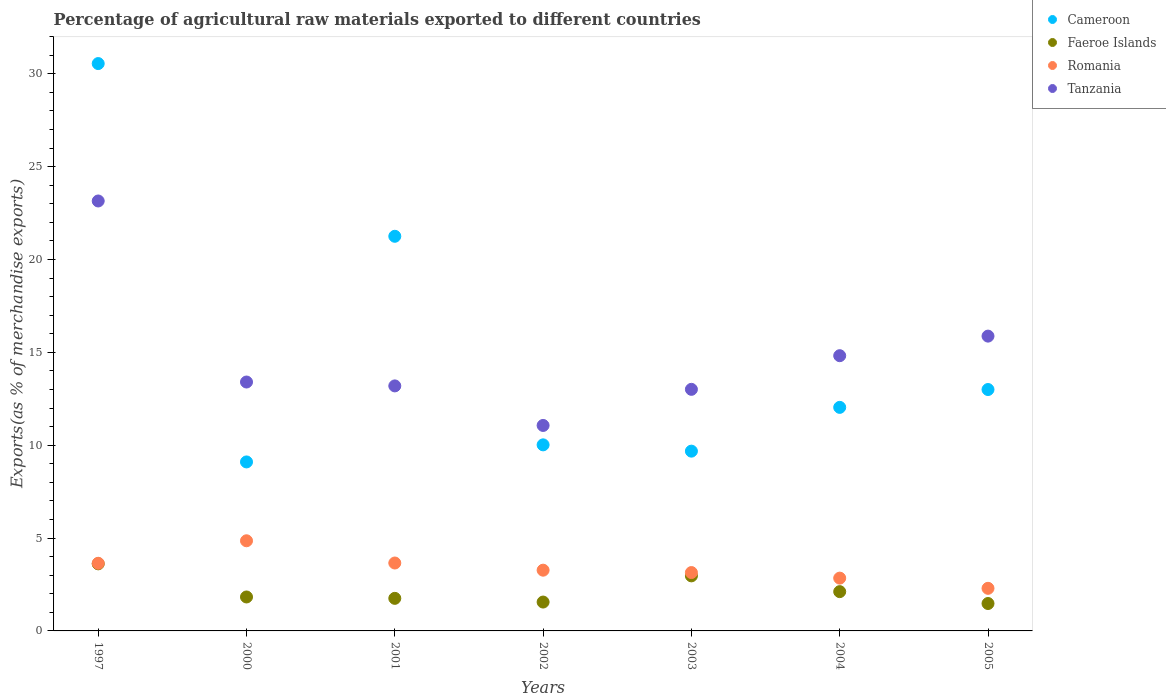How many different coloured dotlines are there?
Provide a short and direct response. 4. What is the percentage of exports to different countries in Cameroon in 2004?
Keep it short and to the point. 12.04. Across all years, what is the maximum percentage of exports to different countries in Faeroe Islands?
Offer a very short reply. 3.61. Across all years, what is the minimum percentage of exports to different countries in Cameroon?
Make the answer very short. 9.1. In which year was the percentage of exports to different countries in Cameroon maximum?
Make the answer very short. 1997. In which year was the percentage of exports to different countries in Tanzania minimum?
Keep it short and to the point. 2002. What is the total percentage of exports to different countries in Cameroon in the graph?
Your response must be concise. 105.64. What is the difference between the percentage of exports to different countries in Faeroe Islands in 2003 and that in 2004?
Provide a short and direct response. 0.85. What is the difference between the percentage of exports to different countries in Cameroon in 1997 and the percentage of exports to different countries in Tanzania in 2005?
Provide a short and direct response. 14.68. What is the average percentage of exports to different countries in Faeroe Islands per year?
Give a very brief answer. 2.19. In the year 2001, what is the difference between the percentage of exports to different countries in Cameroon and percentage of exports to different countries in Romania?
Provide a short and direct response. 17.59. What is the ratio of the percentage of exports to different countries in Tanzania in 2003 to that in 2005?
Your response must be concise. 0.82. Is the difference between the percentage of exports to different countries in Cameroon in 2001 and 2005 greater than the difference between the percentage of exports to different countries in Romania in 2001 and 2005?
Ensure brevity in your answer.  Yes. What is the difference between the highest and the second highest percentage of exports to different countries in Tanzania?
Provide a succinct answer. 7.28. What is the difference between the highest and the lowest percentage of exports to different countries in Cameroon?
Make the answer very short. 21.45. In how many years, is the percentage of exports to different countries in Romania greater than the average percentage of exports to different countries in Romania taken over all years?
Offer a terse response. 3. Is the sum of the percentage of exports to different countries in Faeroe Islands in 2002 and 2003 greater than the maximum percentage of exports to different countries in Romania across all years?
Your answer should be very brief. No. Is it the case that in every year, the sum of the percentage of exports to different countries in Romania and percentage of exports to different countries in Tanzania  is greater than the percentage of exports to different countries in Cameroon?
Your answer should be compact. No. Does the percentage of exports to different countries in Faeroe Islands monotonically increase over the years?
Provide a succinct answer. No. Is the percentage of exports to different countries in Romania strictly greater than the percentage of exports to different countries in Tanzania over the years?
Provide a succinct answer. No. How many dotlines are there?
Give a very brief answer. 4. What is the difference between two consecutive major ticks on the Y-axis?
Offer a terse response. 5. Does the graph contain grids?
Provide a short and direct response. No. Where does the legend appear in the graph?
Offer a terse response. Top right. How many legend labels are there?
Your response must be concise. 4. How are the legend labels stacked?
Your answer should be compact. Vertical. What is the title of the graph?
Your answer should be very brief. Percentage of agricultural raw materials exported to different countries. Does "Kenya" appear as one of the legend labels in the graph?
Your answer should be compact. No. What is the label or title of the X-axis?
Give a very brief answer. Years. What is the label or title of the Y-axis?
Ensure brevity in your answer.  Exports(as % of merchandise exports). What is the Exports(as % of merchandise exports) of Cameroon in 1997?
Your answer should be very brief. 30.55. What is the Exports(as % of merchandise exports) of Faeroe Islands in 1997?
Keep it short and to the point. 3.61. What is the Exports(as % of merchandise exports) of Romania in 1997?
Your response must be concise. 3.64. What is the Exports(as % of merchandise exports) in Tanzania in 1997?
Give a very brief answer. 23.15. What is the Exports(as % of merchandise exports) in Cameroon in 2000?
Offer a terse response. 9.1. What is the Exports(as % of merchandise exports) of Faeroe Islands in 2000?
Ensure brevity in your answer.  1.83. What is the Exports(as % of merchandise exports) in Romania in 2000?
Keep it short and to the point. 4.85. What is the Exports(as % of merchandise exports) of Tanzania in 2000?
Offer a very short reply. 13.4. What is the Exports(as % of merchandise exports) of Cameroon in 2001?
Keep it short and to the point. 21.25. What is the Exports(as % of merchandise exports) of Faeroe Islands in 2001?
Make the answer very short. 1.75. What is the Exports(as % of merchandise exports) of Romania in 2001?
Make the answer very short. 3.66. What is the Exports(as % of merchandise exports) of Tanzania in 2001?
Make the answer very short. 13.19. What is the Exports(as % of merchandise exports) in Cameroon in 2002?
Keep it short and to the point. 10.02. What is the Exports(as % of merchandise exports) of Faeroe Islands in 2002?
Offer a very short reply. 1.55. What is the Exports(as % of merchandise exports) in Romania in 2002?
Keep it short and to the point. 3.27. What is the Exports(as % of merchandise exports) in Tanzania in 2002?
Your answer should be compact. 11.06. What is the Exports(as % of merchandise exports) of Cameroon in 2003?
Your answer should be very brief. 9.68. What is the Exports(as % of merchandise exports) of Faeroe Islands in 2003?
Provide a short and direct response. 2.96. What is the Exports(as % of merchandise exports) in Romania in 2003?
Make the answer very short. 3.14. What is the Exports(as % of merchandise exports) of Tanzania in 2003?
Ensure brevity in your answer.  13.01. What is the Exports(as % of merchandise exports) in Cameroon in 2004?
Ensure brevity in your answer.  12.04. What is the Exports(as % of merchandise exports) in Faeroe Islands in 2004?
Make the answer very short. 2.12. What is the Exports(as % of merchandise exports) of Romania in 2004?
Make the answer very short. 2.84. What is the Exports(as % of merchandise exports) in Tanzania in 2004?
Provide a succinct answer. 14.82. What is the Exports(as % of merchandise exports) of Cameroon in 2005?
Your response must be concise. 13. What is the Exports(as % of merchandise exports) in Faeroe Islands in 2005?
Provide a succinct answer. 1.48. What is the Exports(as % of merchandise exports) in Romania in 2005?
Your response must be concise. 2.29. What is the Exports(as % of merchandise exports) in Tanzania in 2005?
Give a very brief answer. 15.87. Across all years, what is the maximum Exports(as % of merchandise exports) in Cameroon?
Keep it short and to the point. 30.55. Across all years, what is the maximum Exports(as % of merchandise exports) of Faeroe Islands?
Offer a terse response. 3.61. Across all years, what is the maximum Exports(as % of merchandise exports) of Romania?
Your answer should be very brief. 4.85. Across all years, what is the maximum Exports(as % of merchandise exports) in Tanzania?
Your answer should be compact. 23.15. Across all years, what is the minimum Exports(as % of merchandise exports) of Cameroon?
Provide a succinct answer. 9.1. Across all years, what is the minimum Exports(as % of merchandise exports) of Faeroe Islands?
Provide a succinct answer. 1.48. Across all years, what is the minimum Exports(as % of merchandise exports) in Romania?
Make the answer very short. 2.29. Across all years, what is the minimum Exports(as % of merchandise exports) of Tanzania?
Give a very brief answer. 11.06. What is the total Exports(as % of merchandise exports) of Cameroon in the graph?
Provide a succinct answer. 105.64. What is the total Exports(as % of merchandise exports) of Faeroe Islands in the graph?
Your answer should be compact. 15.3. What is the total Exports(as % of merchandise exports) of Romania in the graph?
Ensure brevity in your answer.  23.7. What is the total Exports(as % of merchandise exports) in Tanzania in the graph?
Give a very brief answer. 104.52. What is the difference between the Exports(as % of merchandise exports) of Cameroon in 1997 and that in 2000?
Keep it short and to the point. 21.45. What is the difference between the Exports(as % of merchandise exports) of Faeroe Islands in 1997 and that in 2000?
Your answer should be very brief. 1.78. What is the difference between the Exports(as % of merchandise exports) of Romania in 1997 and that in 2000?
Ensure brevity in your answer.  -1.21. What is the difference between the Exports(as % of merchandise exports) of Tanzania in 1997 and that in 2000?
Your answer should be compact. 9.75. What is the difference between the Exports(as % of merchandise exports) in Cameroon in 1997 and that in 2001?
Ensure brevity in your answer.  9.3. What is the difference between the Exports(as % of merchandise exports) in Faeroe Islands in 1997 and that in 2001?
Offer a terse response. 1.86. What is the difference between the Exports(as % of merchandise exports) of Romania in 1997 and that in 2001?
Your answer should be compact. -0.01. What is the difference between the Exports(as % of merchandise exports) of Tanzania in 1997 and that in 2001?
Give a very brief answer. 9.96. What is the difference between the Exports(as % of merchandise exports) in Cameroon in 1997 and that in 2002?
Offer a terse response. 20.53. What is the difference between the Exports(as % of merchandise exports) in Faeroe Islands in 1997 and that in 2002?
Keep it short and to the point. 2.06. What is the difference between the Exports(as % of merchandise exports) in Romania in 1997 and that in 2002?
Make the answer very short. 0.37. What is the difference between the Exports(as % of merchandise exports) of Tanzania in 1997 and that in 2002?
Provide a short and direct response. 12.09. What is the difference between the Exports(as % of merchandise exports) in Cameroon in 1997 and that in 2003?
Your response must be concise. 20.87. What is the difference between the Exports(as % of merchandise exports) of Faeroe Islands in 1997 and that in 2003?
Offer a terse response. 0.65. What is the difference between the Exports(as % of merchandise exports) in Romania in 1997 and that in 2003?
Provide a succinct answer. 0.5. What is the difference between the Exports(as % of merchandise exports) in Tanzania in 1997 and that in 2003?
Offer a terse response. 10.14. What is the difference between the Exports(as % of merchandise exports) in Cameroon in 1997 and that in 2004?
Provide a short and direct response. 18.51. What is the difference between the Exports(as % of merchandise exports) in Faeroe Islands in 1997 and that in 2004?
Provide a short and direct response. 1.5. What is the difference between the Exports(as % of merchandise exports) of Romania in 1997 and that in 2004?
Your response must be concise. 0.8. What is the difference between the Exports(as % of merchandise exports) in Tanzania in 1997 and that in 2004?
Your answer should be compact. 8.33. What is the difference between the Exports(as % of merchandise exports) in Cameroon in 1997 and that in 2005?
Your answer should be very brief. 17.55. What is the difference between the Exports(as % of merchandise exports) of Faeroe Islands in 1997 and that in 2005?
Your answer should be compact. 2.14. What is the difference between the Exports(as % of merchandise exports) of Romania in 1997 and that in 2005?
Offer a terse response. 1.35. What is the difference between the Exports(as % of merchandise exports) of Tanzania in 1997 and that in 2005?
Your answer should be compact. 7.28. What is the difference between the Exports(as % of merchandise exports) in Cameroon in 2000 and that in 2001?
Your response must be concise. -12.15. What is the difference between the Exports(as % of merchandise exports) in Faeroe Islands in 2000 and that in 2001?
Make the answer very short. 0.07. What is the difference between the Exports(as % of merchandise exports) of Romania in 2000 and that in 2001?
Your answer should be very brief. 1.2. What is the difference between the Exports(as % of merchandise exports) of Tanzania in 2000 and that in 2001?
Your answer should be very brief. 0.21. What is the difference between the Exports(as % of merchandise exports) of Cameroon in 2000 and that in 2002?
Offer a very short reply. -0.92. What is the difference between the Exports(as % of merchandise exports) of Faeroe Islands in 2000 and that in 2002?
Your answer should be very brief. 0.27. What is the difference between the Exports(as % of merchandise exports) of Romania in 2000 and that in 2002?
Provide a succinct answer. 1.58. What is the difference between the Exports(as % of merchandise exports) in Tanzania in 2000 and that in 2002?
Ensure brevity in your answer.  2.34. What is the difference between the Exports(as % of merchandise exports) of Cameroon in 2000 and that in 2003?
Offer a very short reply. -0.58. What is the difference between the Exports(as % of merchandise exports) in Faeroe Islands in 2000 and that in 2003?
Ensure brevity in your answer.  -1.14. What is the difference between the Exports(as % of merchandise exports) of Romania in 2000 and that in 2003?
Make the answer very short. 1.71. What is the difference between the Exports(as % of merchandise exports) of Tanzania in 2000 and that in 2003?
Make the answer very short. 0.39. What is the difference between the Exports(as % of merchandise exports) of Cameroon in 2000 and that in 2004?
Offer a terse response. -2.94. What is the difference between the Exports(as % of merchandise exports) in Faeroe Islands in 2000 and that in 2004?
Offer a very short reply. -0.29. What is the difference between the Exports(as % of merchandise exports) in Romania in 2000 and that in 2004?
Your response must be concise. 2.01. What is the difference between the Exports(as % of merchandise exports) in Tanzania in 2000 and that in 2004?
Provide a succinct answer. -1.42. What is the difference between the Exports(as % of merchandise exports) in Cameroon in 2000 and that in 2005?
Your answer should be very brief. -3.9. What is the difference between the Exports(as % of merchandise exports) of Faeroe Islands in 2000 and that in 2005?
Your answer should be very brief. 0.35. What is the difference between the Exports(as % of merchandise exports) in Romania in 2000 and that in 2005?
Your response must be concise. 2.56. What is the difference between the Exports(as % of merchandise exports) of Tanzania in 2000 and that in 2005?
Offer a very short reply. -2.47. What is the difference between the Exports(as % of merchandise exports) in Cameroon in 2001 and that in 2002?
Your answer should be very brief. 11.23. What is the difference between the Exports(as % of merchandise exports) in Faeroe Islands in 2001 and that in 2002?
Provide a short and direct response. 0.2. What is the difference between the Exports(as % of merchandise exports) in Romania in 2001 and that in 2002?
Ensure brevity in your answer.  0.39. What is the difference between the Exports(as % of merchandise exports) in Tanzania in 2001 and that in 2002?
Your response must be concise. 2.13. What is the difference between the Exports(as % of merchandise exports) of Cameroon in 2001 and that in 2003?
Make the answer very short. 11.57. What is the difference between the Exports(as % of merchandise exports) of Faeroe Islands in 2001 and that in 2003?
Provide a short and direct response. -1.21. What is the difference between the Exports(as % of merchandise exports) of Romania in 2001 and that in 2003?
Keep it short and to the point. 0.51. What is the difference between the Exports(as % of merchandise exports) in Tanzania in 2001 and that in 2003?
Your answer should be very brief. 0.18. What is the difference between the Exports(as % of merchandise exports) of Cameroon in 2001 and that in 2004?
Your answer should be compact. 9.21. What is the difference between the Exports(as % of merchandise exports) of Faeroe Islands in 2001 and that in 2004?
Provide a short and direct response. -0.36. What is the difference between the Exports(as % of merchandise exports) of Romania in 2001 and that in 2004?
Your response must be concise. 0.81. What is the difference between the Exports(as % of merchandise exports) in Tanzania in 2001 and that in 2004?
Give a very brief answer. -1.63. What is the difference between the Exports(as % of merchandise exports) in Cameroon in 2001 and that in 2005?
Ensure brevity in your answer.  8.25. What is the difference between the Exports(as % of merchandise exports) in Faeroe Islands in 2001 and that in 2005?
Provide a short and direct response. 0.28. What is the difference between the Exports(as % of merchandise exports) of Romania in 2001 and that in 2005?
Make the answer very short. 1.36. What is the difference between the Exports(as % of merchandise exports) in Tanzania in 2001 and that in 2005?
Provide a succinct answer. -2.68. What is the difference between the Exports(as % of merchandise exports) of Cameroon in 2002 and that in 2003?
Ensure brevity in your answer.  0.34. What is the difference between the Exports(as % of merchandise exports) in Faeroe Islands in 2002 and that in 2003?
Make the answer very short. -1.41. What is the difference between the Exports(as % of merchandise exports) of Romania in 2002 and that in 2003?
Your answer should be very brief. 0.13. What is the difference between the Exports(as % of merchandise exports) in Tanzania in 2002 and that in 2003?
Your response must be concise. -1.94. What is the difference between the Exports(as % of merchandise exports) of Cameroon in 2002 and that in 2004?
Provide a short and direct response. -2.02. What is the difference between the Exports(as % of merchandise exports) in Faeroe Islands in 2002 and that in 2004?
Offer a terse response. -0.56. What is the difference between the Exports(as % of merchandise exports) of Romania in 2002 and that in 2004?
Give a very brief answer. 0.43. What is the difference between the Exports(as % of merchandise exports) in Tanzania in 2002 and that in 2004?
Keep it short and to the point. -3.76. What is the difference between the Exports(as % of merchandise exports) in Cameroon in 2002 and that in 2005?
Ensure brevity in your answer.  -2.98. What is the difference between the Exports(as % of merchandise exports) of Faeroe Islands in 2002 and that in 2005?
Provide a succinct answer. 0.08. What is the difference between the Exports(as % of merchandise exports) of Romania in 2002 and that in 2005?
Ensure brevity in your answer.  0.98. What is the difference between the Exports(as % of merchandise exports) in Tanzania in 2002 and that in 2005?
Your response must be concise. -4.81. What is the difference between the Exports(as % of merchandise exports) in Cameroon in 2003 and that in 2004?
Provide a succinct answer. -2.36. What is the difference between the Exports(as % of merchandise exports) of Faeroe Islands in 2003 and that in 2004?
Keep it short and to the point. 0.85. What is the difference between the Exports(as % of merchandise exports) of Romania in 2003 and that in 2004?
Your answer should be very brief. 0.3. What is the difference between the Exports(as % of merchandise exports) in Tanzania in 2003 and that in 2004?
Keep it short and to the point. -1.81. What is the difference between the Exports(as % of merchandise exports) of Cameroon in 2003 and that in 2005?
Your answer should be very brief. -3.32. What is the difference between the Exports(as % of merchandise exports) of Faeroe Islands in 2003 and that in 2005?
Your answer should be compact. 1.49. What is the difference between the Exports(as % of merchandise exports) of Romania in 2003 and that in 2005?
Make the answer very short. 0.85. What is the difference between the Exports(as % of merchandise exports) of Tanzania in 2003 and that in 2005?
Your answer should be compact. -2.87. What is the difference between the Exports(as % of merchandise exports) of Cameroon in 2004 and that in 2005?
Your answer should be very brief. -0.96. What is the difference between the Exports(as % of merchandise exports) of Faeroe Islands in 2004 and that in 2005?
Give a very brief answer. 0.64. What is the difference between the Exports(as % of merchandise exports) in Romania in 2004 and that in 2005?
Your response must be concise. 0.55. What is the difference between the Exports(as % of merchandise exports) in Tanzania in 2004 and that in 2005?
Offer a terse response. -1.05. What is the difference between the Exports(as % of merchandise exports) in Cameroon in 1997 and the Exports(as % of merchandise exports) in Faeroe Islands in 2000?
Offer a terse response. 28.72. What is the difference between the Exports(as % of merchandise exports) of Cameroon in 1997 and the Exports(as % of merchandise exports) of Romania in 2000?
Your response must be concise. 25.7. What is the difference between the Exports(as % of merchandise exports) in Cameroon in 1997 and the Exports(as % of merchandise exports) in Tanzania in 2000?
Offer a terse response. 17.15. What is the difference between the Exports(as % of merchandise exports) of Faeroe Islands in 1997 and the Exports(as % of merchandise exports) of Romania in 2000?
Make the answer very short. -1.24. What is the difference between the Exports(as % of merchandise exports) of Faeroe Islands in 1997 and the Exports(as % of merchandise exports) of Tanzania in 2000?
Make the answer very short. -9.79. What is the difference between the Exports(as % of merchandise exports) in Romania in 1997 and the Exports(as % of merchandise exports) in Tanzania in 2000?
Offer a terse response. -9.76. What is the difference between the Exports(as % of merchandise exports) of Cameroon in 1997 and the Exports(as % of merchandise exports) of Faeroe Islands in 2001?
Give a very brief answer. 28.8. What is the difference between the Exports(as % of merchandise exports) of Cameroon in 1997 and the Exports(as % of merchandise exports) of Romania in 2001?
Offer a terse response. 26.89. What is the difference between the Exports(as % of merchandise exports) of Cameroon in 1997 and the Exports(as % of merchandise exports) of Tanzania in 2001?
Provide a short and direct response. 17.36. What is the difference between the Exports(as % of merchandise exports) of Faeroe Islands in 1997 and the Exports(as % of merchandise exports) of Romania in 2001?
Ensure brevity in your answer.  -0.04. What is the difference between the Exports(as % of merchandise exports) of Faeroe Islands in 1997 and the Exports(as % of merchandise exports) of Tanzania in 2001?
Offer a terse response. -9.58. What is the difference between the Exports(as % of merchandise exports) in Romania in 1997 and the Exports(as % of merchandise exports) in Tanzania in 2001?
Provide a succinct answer. -9.55. What is the difference between the Exports(as % of merchandise exports) in Cameroon in 1997 and the Exports(as % of merchandise exports) in Faeroe Islands in 2002?
Offer a terse response. 29. What is the difference between the Exports(as % of merchandise exports) of Cameroon in 1997 and the Exports(as % of merchandise exports) of Romania in 2002?
Keep it short and to the point. 27.28. What is the difference between the Exports(as % of merchandise exports) in Cameroon in 1997 and the Exports(as % of merchandise exports) in Tanzania in 2002?
Give a very brief answer. 19.49. What is the difference between the Exports(as % of merchandise exports) in Faeroe Islands in 1997 and the Exports(as % of merchandise exports) in Romania in 2002?
Your answer should be compact. 0.34. What is the difference between the Exports(as % of merchandise exports) of Faeroe Islands in 1997 and the Exports(as % of merchandise exports) of Tanzania in 2002?
Your answer should be compact. -7.45. What is the difference between the Exports(as % of merchandise exports) in Romania in 1997 and the Exports(as % of merchandise exports) in Tanzania in 2002?
Your answer should be compact. -7.42. What is the difference between the Exports(as % of merchandise exports) of Cameroon in 1997 and the Exports(as % of merchandise exports) of Faeroe Islands in 2003?
Your answer should be very brief. 27.59. What is the difference between the Exports(as % of merchandise exports) in Cameroon in 1997 and the Exports(as % of merchandise exports) in Romania in 2003?
Provide a succinct answer. 27.41. What is the difference between the Exports(as % of merchandise exports) in Cameroon in 1997 and the Exports(as % of merchandise exports) in Tanzania in 2003?
Make the answer very short. 17.54. What is the difference between the Exports(as % of merchandise exports) in Faeroe Islands in 1997 and the Exports(as % of merchandise exports) in Romania in 2003?
Offer a terse response. 0.47. What is the difference between the Exports(as % of merchandise exports) in Faeroe Islands in 1997 and the Exports(as % of merchandise exports) in Tanzania in 2003?
Ensure brevity in your answer.  -9.4. What is the difference between the Exports(as % of merchandise exports) in Romania in 1997 and the Exports(as % of merchandise exports) in Tanzania in 2003?
Keep it short and to the point. -9.37. What is the difference between the Exports(as % of merchandise exports) of Cameroon in 1997 and the Exports(as % of merchandise exports) of Faeroe Islands in 2004?
Your response must be concise. 28.44. What is the difference between the Exports(as % of merchandise exports) in Cameroon in 1997 and the Exports(as % of merchandise exports) in Romania in 2004?
Offer a very short reply. 27.71. What is the difference between the Exports(as % of merchandise exports) in Cameroon in 1997 and the Exports(as % of merchandise exports) in Tanzania in 2004?
Make the answer very short. 15.73. What is the difference between the Exports(as % of merchandise exports) of Faeroe Islands in 1997 and the Exports(as % of merchandise exports) of Romania in 2004?
Offer a very short reply. 0.77. What is the difference between the Exports(as % of merchandise exports) in Faeroe Islands in 1997 and the Exports(as % of merchandise exports) in Tanzania in 2004?
Offer a terse response. -11.21. What is the difference between the Exports(as % of merchandise exports) of Romania in 1997 and the Exports(as % of merchandise exports) of Tanzania in 2004?
Offer a very short reply. -11.18. What is the difference between the Exports(as % of merchandise exports) of Cameroon in 1997 and the Exports(as % of merchandise exports) of Faeroe Islands in 2005?
Your response must be concise. 29.07. What is the difference between the Exports(as % of merchandise exports) in Cameroon in 1997 and the Exports(as % of merchandise exports) in Romania in 2005?
Your response must be concise. 28.26. What is the difference between the Exports(as % of merchandise exports) of Cameroon in 1997 and the Exports(as % of merchandise exports) of Tanzania in 2005?
Your answer should be very brief. 14.68. What is the difference between the Exports(as % of merchandise exports) in Faeroe Islands in 1997 and the Exports(as % of merchandise exports) in Romania in 2005?
Give a very brief answer. 1.32. What is the difference between the Exports(as % of merchandise exports) of Faeroe Islands in 1997 and the Exports(as % of merchandise exports) of Tanzania in 2005?
Provide a short and direct response. -12.26. What is the difference between the Exports(as % of merchandise exports) of Romania in 1997 and the Exports(as % of merchandise exports) of Tanzania in 2005?
Provide a succinct answer. -12.23. What is the difference between the Exports(as % of merchandise exports) of Cameroon in 2000 and the Exports(as % of merchandise exports) of Faeroe Islands in 2001?
Give a very brief answer. 7.35. What is the difference between the Exports(as % of merchandise exports) of Cameroon in 2000 and the Exports(as % of merchandise exports) of Romania in 2001?
Offer a very short reply. 5.44. What is the difference between the Exports(as % of merchandise exports) of Cameroon in 2000 and the Exports(as % of merchandise exports) of Tanzania in 2001?
Your response must be concise. -4.09. What is the difference between the Exports(as % of merchandise exports) in Faeroe Islands in 2000 and the Exports(as % of merchandise exports) in Romania in 2001?
Ensure brevity in your answer.  -1.83. What is the difference between the Exports(as % of merchandise exports) in Faeroe Islands in 2000 and the Exports(as % of merchandise exports) in Tanzania in 2001?
Provide a short and direct response. -11.37. What is the difference between the Exports(as % of merchandise exports) of Romania in 2000 and the Exports(as % of merchandise exports) of Tanzania in 2001?
Ensure brevity in your answer.  -8.34. What is the difference between the Exports(as % of merchandise exports) in Cameroon in 2000 and the Exports(as % of merchandise exports) in Faeroe Islands in 2002?
Keep it short and to the point. 7.55. What is the difference between the Exports(as % of merchandise exports) of Cameroon in 2000 and the Exports(as % of merchandise exports) of Romania in 2002?
Ensure brevity in your answer.  5.83. What is the difference between the Exports(as % of merchandise exports) of Cameroon in 2000 and the Exports(as % of merchandise exports) of Tanzania in 2002?
Offer a terse response. -1.96. What is the difference between the Exports(as % of merchandise exports) of Faeroe Islands in 2000 and the Exports(as % of merchandise exports) of Romania in 2002?
Ensure brevity in your answer.  -1.44. What is the difference between the Exports(as % of merchandise exports) in Faeroe Islands in 2000 and the Exports(as % of merchandise exports) in Tanzania in 2002?
Provide a succinct answer. -9.24. What is the difference between the Exports(as % of merchandise exports) in Romania in 2000 and the Exports(as % of merchandise exports) in Tanzania in 2002?
Your answer should be very brief. -6.21. What is the difference between the Exports(as % of merchandise exports) of Cameroon in 2000 and the Exports(as % of merchandise exports) of Faeroe Islands in 2003?
Give a very brief answer. 6.14. What is the difference between the Exports(as % of merchandise exports) in Cameroon in 2000 and the Exports(as % of merchandise exports) in Romania in 2003?
Make the answer very short. 5.96. What is the difference between the Exports(as % of merchandise exports) of Cameroon in 2000 and the Exports(as % of merchandise exports) of Tanzania in 2003?
Make the answer very short. -3.91. What is the difference between the Exports(as % of merchandise exports) in Faeroe Islands in 2000 and the Exports(as % of merchandise exports) in Romania in 2003?
Give a very brief answer. -1.31. What is the difference between the Exports(as % of merchandise exports) in Faeroe Islands in 2000 and the Exports(as % of merchandise exports) in Tanzania in 2003?
Keep it short and to the point. -11.18. What is the difference between the Exports(as % of merchandise exports) in Romania in 2000 and the Exports(as % of merchandise exports) in Tanzania in 2003?
Give a very brief answer. -8.15. What is the difference between the Exports(as % of merchandise exports) in Cameroon in 2000 and the Exports(as % of merchandise exports) in Faeroe Islands in 2004?
Offer a terse response. 6.98. What is the difference between the Exports(as % of merchandise exports) of Cameroon in 2000 and the Exports(as % of merchandise exports) of Romania in 2004?
Provide a short and direct response. 6.26. What is the difference between the Exports(as % of merchandise exports) in Cameroon in 2000 and the Exports(as % of merchandise exports) in Tanzania in 2004?
Your response must be concise. -5.72. What is the difference between the Exports(as % of merchandise exports) in Faeroe Islands in 2000 and the Exports(as % of merchandise exports) in Romania in 2004?
Your response must be concise. -1.01. What is the difference between the Exports(as % of merchandise exports) in Faeroe Islands in 2000 and the Exports(as % of merchandise exports) in Tanzania in 2004?
Give a very brief answer. -12.99. What is the difference between the Exports(as % of merchandise exports) of Romania in 2000 and the Exports(as % of merchandise exports) of Tanzania in 2004?
Your answer should be very brief. -9.97. What is the difference between the Exports(as % of merchandise exports) of Cameroon in 2000 and the Exports(as % of merchandise exports) of Faeroe Islands in 2005?
Your answer should be compact. 7.62. What is the difference between the Exports(as % of merchandise exports) in Cameroon in 2000 and the Exports(as % of merchandise exports) in Romania in 2005?
Make the answer very short. 6.81. What is the difference between the Exports(as % of merchandise exports) of Cameroon in 2000 and the Exports(as % of merchandise exports) of Tanzania in 2005?
Offer a very short reply. -6.77. What is the difference between the Exports(as % of merchandise exports) in Faeroe Islands in 2000 and the Exports(as % of merchandise exports) in Romania in 2005?
Keep it short and to the point. -0.47. What is the difference between the Exports(as % of merchandise exports) of Faeroe Islands in 2000 and the Exports(as % of merchandise exports) of Tanzania in 2005?
Make the answer very short. -14.05. What is the difference between the Exports(as % of merchandise exports) in Romania in 2000 and the Exports(as % of merchandise exports) in Tanzania in 2005?
Keep it short and to the point. -11.02. What is the difference between the Exports(as % of merchandise exports) of Cameroon in 2001 and the Exports(as % of merchandise exports) of Faeroe Islands in 2002?
Provide a short and direct response. 19.7. What is the difference between the Exports(as % of merchandise exports) in Cameroon in 2001 and the Exports(as % of merchandise exports) in Romania in 2002?
Give a very brief answer. 17.98. What is the difference between the Exports(as % of merchandise exports) in Cameroon in 2001 and the Exports(as % of merchandise exports) in Tanzania in 2002?
Your answer should be very brief. 10.19. What is the difference between the Exports(as % of merchandise exports) in Faeroe Islands in 2001 and the Exports(as % of merchandise exports) in Romania in 2002?
Your answer should be compact. -1.52. What is the difference between the Exports(as % of merchandise exports) in Faeroe Islands in 2001 and the Exports(as % of merchandise exports) in Tanzania in 2002?
Make the answer very short. -9.31. What is the difference between the Exports(as % of merchandise exports) of Romania in 2001 and the Exports(as % of merchandise exports) of Tanzania in 2002?
Give a very brief answer. -7.41. What is the difference between the Exports(as % of merchandise exports) in Cameroon in 2001 and the Exports(as % of merchandise exports) in Faeroe Islands in 2003?
Offer a terse response. 18.29. What is the difference between the Exports(as % of merchandise exports) of Cameroon in 2001 and the Exports(as % of merchandise exports) of Romania in 2003?
Give a very brief answer. 18.11. What is the difference between the Exports(as % of merchandise exports) of Cameroon in 2001 and the Exports(as % of merchandise exports) of Tanzania in 2003?
Offer a terse response. 8.24. What is the difference between the Exports(as % of merchandise exports) of Faeroe Islands in 2001 and the Exports(as % of merchandise exports) of Romania in 2003?
Your answer should be compact. -1.39. What is the difference between the Exports(as % of merchandise exports) in Faeroe Islands in 2001 and the Exports(as % of merchandise exports) in Tanzania in 2003?
Provide a short and direct response. -11.25. What is the difference between the Exports(as % of merchandise exports) of Romania in 2001 and the Exports(as % of merchandise exports) of Tanzania in 2003?
Provide a short and direct response. -9.35. What is the difference between the Exports(as % of merchandise exports) of Cameroon in 2001 and the Exports(as % of merchandise exports) of Faeroe Islands in 2004?
Your response must be concise. 19.14. What is the difference between the Exports(as % of merchandise exports) of Cameroon in 2001 and the Exports(as % of merchandise exports) of Romania in 2004?
Your answer should be compact. 18.41. What is the difference between the Exports(as % of merchandise exports) in Cameroon in 2001 and the Exports(as % of merchandise exports) in Tanzania in 2004?
Your answer should be very brief. 6.43. What is the difference between the Exports(as % of merchandise exports) of Faeroe Islands in 2001 and the Exports(as % of merchandise exports) of Romania in 2004?
Your answer should be very brief. -1.09. What is the difference between the Exports(as % of merchandise exports) in Faeroe Islands in 2001 and the Exports(as % of merchandise exports) in Tanzania in 2004?
Your answer should be very brief. -13.07. What is the difference between the Exports(as % of merchandise exports) in Romania in 2001 and the Exports(as % of merchandise exports) in Tanzania in 2004?
Provide a short and direct response. -11.16. What is the difference between the Exports(as % of merchandise exports) in Cameroon in 2001 and the Exports(as % of merchandise exports) in Faeroe Islands in 2005?
Offer a terse response. 19.77. What is the difference between the Exports(as % of merchandise exports) in Cameroon in 2001 and the Exports(as % of merchandise exports) in Romania in 2005?
Give a very brief answer. 18.96. What is the difference between the Exports(as % of merchandise exports) of Cameroon in 2001 and the Exports(as % of merchandise exports) of Tanzania in 2005?
Your answer should be compact. 5.38. What is the difference between the Exports(as % of merchandise exports) of Faeroe Islands in 2001 and the Exports(as % of merchandise exports) of Romania in 2005?
Your answer should be compact. -0.54. What is the difference between the Exports(as % of merchandise exports) of Faeroe Islands in 2001 and the Exports(as % of merchandise exports) of Tanzania in 2005?
Ensure brevity in your answer.  -14.12. What is the difference between the Exports(as % of merchandise exports) in Romania in 2001 and the Exports(as % of merchandise exports) in Tanzania in 2005?
Provide a short and direct response. -12.22. What is the difference between the Exports(as % of merchandise exports) of Cameroon in 2002 and the Exports(as % of merchandise exports) of Faeroe Islands in 2003?
Give a very brief answer. 7.06. What is the difference between the Exports(as % of merchandise exports) in Cameroon in 2002 and the Exports(as % of merchandise exports) in Romania in 2003?
Offer a terse response. 6.88. What is the difference between the Exports(as % of merchandise exports) of Cameroon in 2002 and the Exports(as % of merchandise exports) of Tanzania in 2003?
Make the answer very short. -2.99. What is the difference between the Exports(as % of merchandise exports) in Faeroe Islands in 2002 and the Exports(as % of merchandise exports) in Romania in 2003?
Provide a succinct answer. -1.59. What is the difference between the Exports(as % of merchandise exports) in Faeroe Islands in 2002 and the Exports(as % of merchandise exports) in Tanzania in 2003?
Provide a succinct answer. -11.45. What is the difference between the Exports(as % of merchandise exports) of Romania in 2002 and the Exports(as % of merchandise exports) of Tanzania in 2003?
Offer a terse response. -9.74. What is the difference between the Exports(as % of merchandise exports) in Cameroon in 2002 and the Exports(as % of merchandise exports) in Faeroe Islands in 2004?
Keep it short and to the point. 7.9. What is the difference between the Exports(as % of merchandise exports) in Cameroon in 2002 and the Exports(as % of merchandise exports) in Romania in 2004?
Offer a terse response. 7.18. What is the difference between the Exports(as % of merchandise exports) in Cameroon in 2002 and the Exports(as % of merchandise exports) in Tanzania in 2004?
Give a very brief answer. -4.8. What is the difference between the Exports(as % of merchandise exports) in Faeroe Islands in 2002 and the Exports(as % of merchandise exports) in Romania in 2004?
Keep it short and to the point. -1.29. What is the difference between the Exports(as % of merchandise exports) of Faeroe Islands in 2002 and the Exports(as % of merchandise exports) of Tanzania in 2004?
Keep it short and to the point. -13.27. What is the difference between the Exports(as % of merchandise exports) of Romania in 2002 and the Exports(as % of merchandise exports) of Tanzania in 2004?
Your answer should be compact. -11.55. What is the difference between the Exports(as % of merchandise exports) in Cameroon in 2002 and the Exports(as % of merchandise exports) in Faeroe Islands in 2005?
Offer a terse response. 8.54. What is the difference between the Exports(as % of merchandise exports) of Cameroon in 2002 and the Exports(as % of merchandise exports) of Romania in 2005?
Ensure brevity in your answer.  7.73. What is the difference between the Exports(as % of merchandise exports) in Cameroon in 2002 and the Exports(as % of merchandise exports) in Tanzania in 2005?
Make the answer very short. -5.85. What is the difference between the Exports(as % of merchandise exports) of Faeroe Islands in 2002 and the Exports(as % of merchandise exports) of Romania in 2005?
Give a very brief answer. -0.74. What is the difference between the Exports(as % of merchandise exports) of Faeroe Islands in 2002 and the Exports(as % of merchandise exports) of Tanzania in 2005?
Your answer should be very brief. -14.32. What is the difference between the Exports(as % of merchandise exports) of Romania in 2002 and the Exports(as % of merchandise exports) of Tanzania in 2005?
Keep it short and to the point. -12.6. What is the difference between the Exports(as % of merchandise exports) in Cameroon in 2003 and the Exports(as % of merchandise exports) in Faeroe Islands in 2004?
Provide a succinct answer. 7.57. What is the difference between the Exports(as % of merchandise exports) of Cameroon in 2003 and the Exports(as % of merchandise exports) of Romania in 2004?
Offer a terse response. 6.84. What is the difference between the Exports(as % of merchandise exports) of Cameroon in 2003 and the Exports(as % of merchandise exports) of Tanzania in 2004?
Make the answer very short. -5.14. What is the difference between the Exports(as % of merchandise exports) in Faeroe Islands in 2003 and the Exports(as % of merchandise exports) in Romania in 2004?
Give a very brief answer. 0.12. What is the difference between the Exports(as % of merchandise exports) of Faeroe Islands in 2003 and the Exports(as % of merchandise exports) of Tanzania in 2004?
Give a very brief answer. -11.86. What is the difference between the Exports(as % of merchandise exports) in Romania in 2003 and the Exports(as % of merchandise exports) in Tanzania in 2004?
Make the answer very short. -11.68. What is the difference between the Exports(as % of merchandise exports) of Cameroon in 2003 and the Exports(as % of merchandise exports) of Faeroe Islands in 2005?
Make the answer very short. 8.2. What is the difference between the Exports(as % of merchandise exports) of Cameroon in 2003 and the Exports(as % of merchandise exports) of Romania in 2005?
Your response must be concise. 7.39. What is the difference between the Exports(as % of merchandise exports) of Cameroon in 2003 and the Exports(as % of merchandise exports) of Tanzania in 2005?
Offer a very short reply. -6.19. What is the difference between the Exports(as % of merchandise exports) in Faeroe Islands in 2003 and the Exports(as % of merchandise exports) in Romania in 2005?
Ensure brevity in your answer.  0.67. What is the difference between the Exports(as % of merchandise exports) in Faeroe Islands in 2003 and the Exports(as % of merchandise exports) in Tanzania in 2005?
Provide a succinct answer. -12.91. What is the difference between the Exports(as % of merchandise exports) in Romania in 2003 and the Exports(as % of merchandise exports) in Tanzania in 2005?
Offer a terse response. -12.73. What is the difference between the Exports(as % of merchandise exports) of Cameroon in 2004 and the Exports(as % of merchandise exports) of Faeroe Islands in 2005?
Offer a terse response. 10.56. What is the difference between the Exports(as % of merchandise exports) of Cameroon in 2004 and the Exports(as % of merchandise exports) of Romania in 2005?
Give a very brief answer. 9.74. What is the difference between the Exports(as % of merchandise exports) of Cameroon in 2004 and the Exports(as % of merchandise exports) of Tanzania in 2005?
Offer a terse response. -3.84. What is the difference between the Exports(as % of merchandise exports) in Faeroe Islands in 2004 and the Exports(as % of merchandise exports) in Romania in 2005?
Give a very brief answer. -0.18. What is the difference between the Exports(as % of merchandise exports) in Faeroe Islands in 2004 and the Exports(as % of merchandise exports) in Tanzania in 2005?
Provide a succinct answer. -13.76. What is the difference between the Exports(as % of merchandise exports) in Romania in 2004 and the Exports(as % of merchandise exports) in Tanzania in 2005?
Provide a short and direct response. -13.03. What is the average Exports(as % of merchandise exports) of Cameroon per year?
Your answer should be very brief. 15.09. What is the average Exports(as % of merchandise exports) in Faeroe Islands per year?
Offer a terse response. 2.19. What is the average Exports(as % of merchandise exports) of Romania per year?
Make the answer very short. 3.39. What is the average Exports(as % of merchandise exports) in Tanzania per year?
Your response must be concise. 14.93. In the year 1997, what is the difference between the Exports(as % of merchandise exports) of Cameroon and Exports(as % of merchandise exports) of Faeroe Islands?
Make the answer very short. 26.94. In the year 1997, what is the difference between the Exports(as % of merchandise exports) of Cameroon and Exports(as % of merchandise exports) of Romania?
Provide a short and direct response. 26.91. In the year 1997, what is the difference between the Exports(as % of merchandise exports) of Cameroon and Exports(as % of merchandise exports) of Tanzania?
Your answer should be compact. 7.4. In the year 1997, what is the difference between the Exports(as % of merchandise exports) in Faeroe Islands and Exports(as % of merchandise exports) in Romania?
Offer a very short reply. -0.03. In the year 1997, what is the difference between the Exports(as % of merchandise exports) in Faeroe Islands and Exports(as % of merchandise exports) in Tanzania?
Keep it short and to the point. -19.54. In the year 1997, what is the difference between the Exports(as % of merchandise exports) of Romania and Exports(as % of merchandise exports) of Tanzania?
Make the answer very short. -19.51. In the year 2000, what is the difference between the Exports(as % of merchandise exports) of Cameroon and Exports(as % of merchandise exports) of Faeroe Islands?
Ensure brevity in your answer.  7.27. In the year 2000, what is the difference between the Exports(as % of merchandise exports) in Cameroon and Exports(as % of merchandise exports) in Romania?
Your answer should be very brief. 4.25. In the year 2000, what is the difference between the Exports(as % of merchandise exports) of Cameroon and Exports(as % of merchandise exports) of Tanzania?
Offer a very short reply. -4.3. In the year 2000, what is the difference between the Exports(as % of merchandise exports) of Faeroe Islands and Exports(as % of merchandise exports) of Romania?
Provide a short and direct response. -3.03. In the year 2000, what is the difference between the Exports(as % of merchandise exports) of Faeroe Islands and Exports(as % of merchandise exports) of Tanzania?
Make the answer very short. -11.57. In the year 2000, what is the difference between the Exports(as % of merchandise exports) of Romania and Exports(as % of merchandise exports) of Tanzania?
Give a very brief answer. -8.55. In the year 2001, what is the difference between the Exports(as % of merchandise exports) in Cameroon and Exports(as % of merchandise exports) in Faeroe Islands?
Ensure brevity in your answer.  19.5. In the year 2001, what is the difference between the Exports(as % of merchandise exports) in Cameroon and Exports(as % of merchandise exports) in Romania?
Provide a short and direct response. 17.59. In the year 2001, what is the difference between the Exports(as % of merchandise exports) of Cameroon and Exports(as % of merchandise exports) of Tanzania?
Make the answer very short. 8.06. In the year 2001, what is the difference between the Exports(as % of merchandise exports) of Faeroe Islands and Exports(as % of merchandise exports) of Romania?
Ensure brevity in your answer.  -1.9. In the year 2001, what is the difference between the Exports(as % of merchandise exports) in Faeroe Islands and Exports(as % of merchandise exports) in Tanzania?
Make the answer very short. -11.44. In the year 2001, what is the difference between the Exports(as % of merchandise exports) of Romania and Exports(as % of merchandise exports) of Tanzania?
Your answer should be very brief. -9.54. In the year 2002, what is the difference between the Exports(as % of merchandise exports) in Cameroon and Exports(as % of merchandise exports) in Faeroe Islands?
Ensure brevity in your answer.  8.47. In the year 2002, what is the difference between the Exports(as % of merchandise exports) of Cameroon and Exports(as % of merchandise exports) of Romania?
Provide a short and direct response. 6.75. In the year 2002, what is the difference between the Exports(as % of merchandise exports) of Cameroon and Exports(as % of merchandise exports) of Tanzania?
Offer a terse response. -1.04. In the year 2002, what is the difference between the Exports(as % of merchandise exports) in Faeroe Islands and Exports(as % of merchandise exports) in Romania?
Ensure brevity in your answer.  -1.72. In the year 2002, what is the difference between the Exports(as % of merchandise exports) in Faeroe Islands and Exports(as % of merchandise exports) in Tanzania?
Ensure brevity in your answer.  -9.51. In the year 2002, what is the difference between the Exports(as % of merchandise exports) of Romania and Exports(as % of merchandise exports) of Tanzania?
Ensure brevity in your answer.  -7.79. In the year 2003, what is the difference between the Exports(as % of merchandise exports) in Cameroon and Exports(as % of merchandise exports) in Faeroe Islands?
Your answer should be very brief. 6.72. In the year 2003, what is the difference between the Exports(as % of merchandise exports) of Cameroon and Exports(as % of merchandise exports) of Romania?
Offer a terse response. 6.54. In the year 2003, what is the difference between the Exports(as % of merchandise exports) of Cameroon and Exports(as % of merchandise exports) of Tanzania?
Offer a terse response. -3.33. In the year 2003, what is the difference between the Exports(as % of merchandise exports) in Faeroe Islands and Exports(as % of merchandise exports) in Romania?
Your response must be concise. -0.18. In the year 2003, what is the difference between the Exports(as % of merchandise exports) of Faeroe Islands and Exports(as % of merchandise exports) of Tanzania?
Give a very brief answer. -10.04. In the year 2003, what is the difference between the Exports(as % of merchandise exports) in Romania and Exports(as % of merchandise exports) in Tanzania?
Make the answer very short. -9.87. In the year 2004, what is the difference between the Exports(as % of merchandise exports) of Cameroon and Exports(as % of merchandise exports) of Faeroe Islands?
Your answer should be compact. 9.92. In the year 2004, what is the difference between the Exports(as % of merchandise exports) in Cameroon and Exports(as % of merchandise exports) in Romania?
Make the answer very short. 9.2. In the year 2004, what is the difference between the Exports(as % of merchandise exports) in Cameroon and Exports(as % of merchandise exports) in Tanzania?
Make the answer very short. -2.78. In the year 2004, what is the difference between the Exports(as % of merchandise exports) of Faeroe Islands and Exports(as % of merchandise exports) of Romania?
Your answer should be very brief. -0.73. In the year 2004, what is the difference between the Exports(as % of merchandise exports) in Faeroe Islands and Exports(as % of merchandise exports) in Tanzania?
Make the answer very short. -12.71. In the year 2004, what is the difference between the Exports(as % of merchandise exports) of Romania and Exports(as % of merchandise exports) of Tanzania?
Offer a very short reply. -11.98. In the year 2005, what is the difference between the Exports(as % of merchandise exports) in Cameroon and Exports(as % of merchandise exports) in Faeroe Islands?
Give a very brief answer. 11.52. In the year 2005, what is the difference between the Exports(as % of merchandise exports) of Cameroon and Exports(as % of merchandise exports) of Romania?
Keep it short and to the point. 10.7. In the year 2005, what is the difference between the Exports(as % of merchandise exports) of Cameroon and Exports(as % of merchandise exports) of Tanzania?
Give a very brief answer. -2.88. In the year 2005, what is the difference between the Exports(as % of merchandise exports) in Faeroe Islands and Exports(as % of merchandise exports) in Romania?
Your answer should be compact. -0.82. In the year 2005, what is the difference between the Exports(as % of merchandise exports) of Faeroe Islands and Exports(as % of merchandise exports) of Tanzania?
Give a very brief answer. -14.4. In the year 2005, what is the difference between the Exports(as % of merchandise exports) of Romania and Exports(as % of merchandise exports) of Tanzania?
Ensure brevity in your answer.  -13.58. What is the ratio of the Exports(as % of merchandise exports) of Cameroon in 1997 to that in 2000?
Ensure brevity in your answer.  3.36. What is the ratio of the Exports(as % of merchandise exports) in Faeroe Islands in 1997 to that in 2000?
Provide a short and direct response. 1.98. What is the ratio of the Exports(as % of merchandise exports) in Romania in 1997 to that in 2000?
Keep it short and to the point. 0.75. What is the ratio of the Exports(as % of merchandise exports) in Tanzania in 1997 to that in 2000?
Keep it short and to the point. 1.73. What is the ratio of the Exports(as % of merchandise exports) of Cameroon in 1997 to that in 2001?
Make the answer very short. 1.44. What is the ratio of the Exports(as % of merchandise exports) of Faeroe Islands in 1997 to that in 2001?
Offer a very short reply. 2.06. What is the ratio of the Exports(as % of merchandise exports) of Tanzania in 1997 to that in 2001?
Offer a terse response. 1.75. What is the ratio of the Exports(as % of merchandise exports) of Cameroon in 1997 to that in 2002?
Provide a succinct answer. 3.05. What is the ratio of the Exports(as % of merchandise exports) of Faeroe Islands in 1997 to that in 2002?
Offer a very short reply. 2.32. What is the ratio of the Exports(as % of merchandise exports) of Romania in 1997 to that in 2002?
Ensure brevity in your answer.  1.11. What is the ratio of the Exports(as % of merchandise exports) in Tanzania in 1997 to that in 2002?
Your answer should be very brief. 2.09. What is the ratio of the Exports(as % of merchandise exports) of Cameroon in 1997 to that in 2003?
Offer a terse response. 3.16. What is the ratio of the Exports(as % of merchandise exports) of Faeroe Islands in 1997 to that in 2003?
Your response must be concise. 1.22. What is the ratio of the Exports(as % of merchandise exports) of Romania in 1997 to that in 2003?
Your answer should be compact. 1.16. What is the ratio of the Exports(as % of merchandise exports) of Tanzania in 1997 to that in 2003?
Your answer should be compact. 1.78. What is the ratio of the Exports(as % of merchandise exports) of Cameroon in 1997 to that in 2004?
Make the answer very short. 2.54. What is the ratio of the Exports(as % of merchandise exports) of Faeroe Islands in 1997 to that in 2004?
Offer a terse response. 1.71. What is the ratio of the Exports(as % of merchandise exports) of Romania in 1997 to that in 2004?
Keep it short and to the point. 1.28. What is the ratio of the Exports(as % of merchandise exports) in Tanzania in 1997 to that in 2004?
Your response must be concise. 1.56. What is the ratio of the Exports(as % of merchandise exports) in Cameroon in 1997 to that in 2005?
Make the answer very short. 2.35. What is the ratio of the Exports(as % of merchandise exports) of Faeroe Islands in 1997 to that in 2005?
Provide a short and direct response. 2.45. What is the ratio of the Exports(as % of merchandise exports) in Romania in 1997 to that in 2005?
Your answer should be very brief. 1.59. What is the ratio of the Exports(as % of merchandise exports) in Tanzania in 1997 to that in 2005?
Keep it short and to the point. 1.46. What is the ratio of the Exports(as % of merchandise exports) in Cameroon in 2000 to that in 2001?
Your answer should be compact. 0.43. What is the ratio of the Exports(as % of merchandise exports) of Faeroe Islands in 2000 to that in 2001?
Give a very brief answer. 1.04. What is the ratio of the Exports(as % of merchandise exports) of Romania in 2000 to that in 2001?
Make the answer very short. 1.33. What is the ratio of the Exports(as % of merchandise exports) of Tanzania in 2000 to that in 2001?
Provide a short and direct response. 1.02. What is the ratio of the Exports(as % of merchandise exports) of Cameroon in 2000 to that in 2002?
Offer a very short reply. 0.91. What is the ratio of the Exports(as % of merchandise exports) of Faeroe Islands in 2000 to that in 2002?
Your answer should be compact. 1.18. What is the ratio of the Exports(as % of merchandise exports) in Romania in 2000 to that in 2002?
Make the answer very short. 1.48. What is the ratio of the Exports(as % of merchandise exports) in Tanzania in 2000 to that in 2002?
Provide a short and direct response. 1.21. What is the ratio of the Exports(as % of merchandise exports) of Faeroe Islands in 2000 to that in 2003?
Make the answer very short. 0.62. What is the ratio of the Exports(as % of merchandise exports) of Romania in 2000 to that in 2003?
Offer a very short reply. 1.54. What is the ratio of the Exports(as % of merchandise exports) of Tanzania in 2000 to that in 2003?
Your answer should be compact. 1.03. What is the ratio of the Exports(as % of merchandise exports) in Cameroon in 2000 to that in 2004?
Keep it short and to the point. 0.76. What is the ratio of the Exports(as % of merchandise exports) in Faeroe Islands in 2000 to that in 2004?
Offer a very short reply. 0.86. What is the ratio of the Exports(as % of merchandise exports) in Romania in 2000 to that in 2004?
Offer a terse response. 1.71. What is the ratio of the Exports(as % of merchandise exports) of Tanzania in 2000 to that in 2004?
Your response must be concise. 0.9. What is the ratio of the Exports(as % of merchandise exports) in Cameroon in 2000 to that in 2005?
Your answer should be very brief. 0.7. What is the ratio of the Exports(as % of merchandise exports) in Faeroe Islands in 2000 to that in 2005?
Give a very brief answer. 1.24. What is the ratio of the Exports(as % of merchandise exports) in Romania in 2000 to that in 2005?
Your answer should be very brief. 2.12. What is the ratio of the Exports(as % of merchandise exports) of Tanzania in 2000 to that in 2005?
Ensure brevity in your answer.  0.84. What is the ratio of the Exports(as % of merchandise exports) of Cameroon in 2001 to that in 2002?
Provide a succinct answer. 2.12. What is the ratio of the Exports(as % of merchandise exports) of Faeroe Islands in 2001 to that in 2002?
Offer a terse response. 1.13. What is the ratio of the Exports(as % of merchandise exports) of Romania in 2001 to that in 2002?
Your response must be concise. 1.12. What is the ratio of the Exports(as % of merchandise exports) of Tanzania in 2001 to that in 2002?
Make the answer very short. 1.19. What is the ratio of the Exports(as % of merchandise exports) in Cameroon in 2001 to that in 2003?
Offer a terse response. 2.2. What is the ratio of the Exports(as % of merchandise exports) of Faeroe Islands in 2001 to that in 2003?
Keep it short and to the point. 0.59. What is the ratio of the Exports(as % of merchandise exports) of Romania in 2001 to that in 2003?
Keep it short and to the point. 1.16. What is the ratio of the Exports(as % of merchandise exports) in Tanzania in 2001 to that in 2003?
Offer a terse response. 1.01. What is the ratio of the Exports(as % of merchandise exports) in Cameroon in 2001 to that in 2004?
Make the answer very short. 1.77. What is the ratio of the Exports(as % of merchandise exports) of Faeroe Islands in 2001 to that in 2004?
Your answer should be compact. 0.83. What is the ratio of the Exports(as % of merchandise exports) of Romania in 2001 to that in 2004?
Provide a short and direct response. 1.29. What is the ratio of the Exports(as % of merchandise exports) of Tanzania in 2001 to that in 2004?
Give a very brief answer. 0.89. What is the ratio of the Exports(as % of merchandise exports) in Cameroon in 2001 to that in 2005?
Ensure brevity in your answer.  1.63. What is the ratio of the Exports(as % of merchandise exports) in Faeroe Islands in 2001 to that in 2005?
Keep it short and to the point. 1.19. What is the ratio of the Exports(as % of merchandise exports) in Romania in 2001 to that in 2005?
Offer a terse response. 1.59. What is the ratio of the Exports(as % of merchandise exports) in Tanzania in 2001 to that in 2005?
Offer a terse response. 0.83. What is the ratio of the Exports(as % of merchandise exports) in Cameroon in 2002 to that in 2003?
Make the answer very short. 1.03. What is the ratio of the Exports(as % of merchandise exports) in Faeroe Islands in 2002 to that in 2003?
Your answer should be very brief. 0.52. What is the ratio of the Exports(as % of merchandise exports) of Romania in 2002 to that in 2003?
Offer a terse response. 1.04. What is the ratio of the Exports(as % of merchandise exports) of Tanzania in 2002 to that in 2003?
Give a very brief answer. 0.85. What is the ratio of the Exports(as % of merchandise exports) in Cameroon in 2002 to that in 2004?
Make the answer very short. 0.83. What is the ratio of the Exports(as % of merchandise exports) in Faeroe Islands in 2002 to that in 2004?
Offer a terse response. 0.73. What is the ratio of the Exports(as % of merchandise exports) of Romania in 2002 to that in 2004?
Your answer should be very brief. 1.15. What is the ratio of the Exports(as % of merchandise exports) of Tanzania in 2002 to that in 2004?
Give a very brief answer. 0.75. What is the ratio of the Exports(as % of merchandise exports) in Cameroon in 2002 to that in 2005?
Your response must be concise. 0.77. What is the ratio of the Exports(as % of merchandise exports) of Faeroe Islands in 2002 to that in 2005?
Give a very brief answer. 1.05. What is the ratio of the Exports(as % of merchandise exports) in Romania in 2002 to that in 2005?
Ensure brevity in your answer.  1.43. What is the ratio of the Exports(as % of merchandise exports) of Tanzania in 2002 to that in 2005?
Ensure brevity in your answer.  0.7. What is the ratio of the Exports(as % of merchandise exports) in Cameroon in 2003 to that in 2004?
Your response must be concise. 0.8. What is the ratio of the Exports(as % of merchandise exports) of Faeroe Islands in 2003 to that in 2004?
Your answer should be very brief. 1.4. What is the ratio of the Exports(as % of merchandise exports) in Romania in 2003 to that in 2004?
Your answer should be compact. 1.11. What is the ratio of the Exports(as % of merchandise exports) of Tanzania in 2003 to that in 2004?
Your response must be concise. 0.88. What is the ratio of the Exports(as % of merchandise exports) in Cameroon in 2003 to that in 2005?
Offer a very short reply. 0.74. What is the ratio of the Exports(as % of merchandise exports) of Faeroe Islands in 2003 to that in 2005?
Provide a short and direct response. 2.01. What is the ratio of the Exports(as % of merchandise exports) of Romania in 2003 to that in 2005?
Make the answer very short. 1.37. What is the ratio of the Exports(as % of merchandise exports) of Tanzania in 2003 to that in 2005?
Make the answer very short. 0.82. What is the ratio of the Exports(as % of merchandise exports) of Cameroon in 2004 to that in 2005?
Offer a terse response. 0.93. What is the ratio of the Exports(as % of merchandise exports) of Faeroe Islands in 2004 to that in 2005?
Your answer should be very brief. 1.43. What is the ratio of the Exports(as % of merchandise exports) of Romania in 2004 to that in 2005?
Give a very brief answer. 1.24. What is the ratio of the Exports(as % of merchandise exports) of Tanzania in 2004 to that in 2005?
Provide a succinct answer. 0.93. What is the difference between the highest and the second highest Exports(as % of merchandise exports) in Cameroon?
Provide a short and direct response. 9.3. What is the difference between the highest and the second highest Exports(as % of merchandise exports) of Faeroe Islands?
Make the answer very short. 0.65. What is the difference between the highest and the second highest Exports(as % of merchandise exports) of Romania?
Provide a short and direct response. 1.2. What is the difference between the highest and the second highest Exports(as % of merchandise exports) in Tanzania?
Offer a very short reply. 7.28. What is the difference between the highest and the lowest Exports(as % of merchandise exports) in Cameroon?
Offer a very short reply. 21.45. What is the difference between the highest and the lowest Exports(as % of merchandise exports) in Faeroe Islands?
Provide a short and direct response. 2.14. What is the difference between the highest and the lowest Exports(as % of merchandise exports) of Romania?
Offer a very short reply. 2.56. What is the difference between the highest and the lowest Exports(as % of merchandise exports) in Tanzania?
Offer a very short reply. 12.09. 